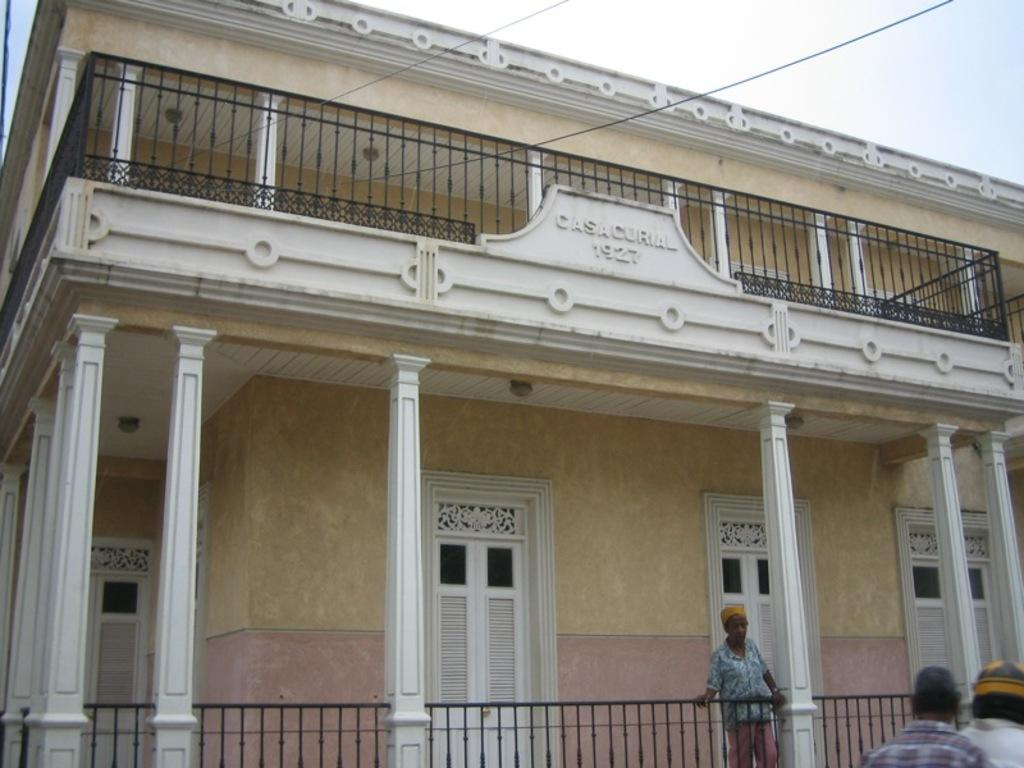What type of structure is present in the image? There is a building in the image. Can you describe the person's position in relation to the building? The person is standing in front of the grilles. Are there any other people visible in the image? Yes, there are people visible at the right side of the image. What type of machine is being operated by the person in the image? There is no machine visible in the image; the person is standing in front of the grilles. What industry is represented by the building in the image? The image does not provide enough information to determine the industry represented by the building. 